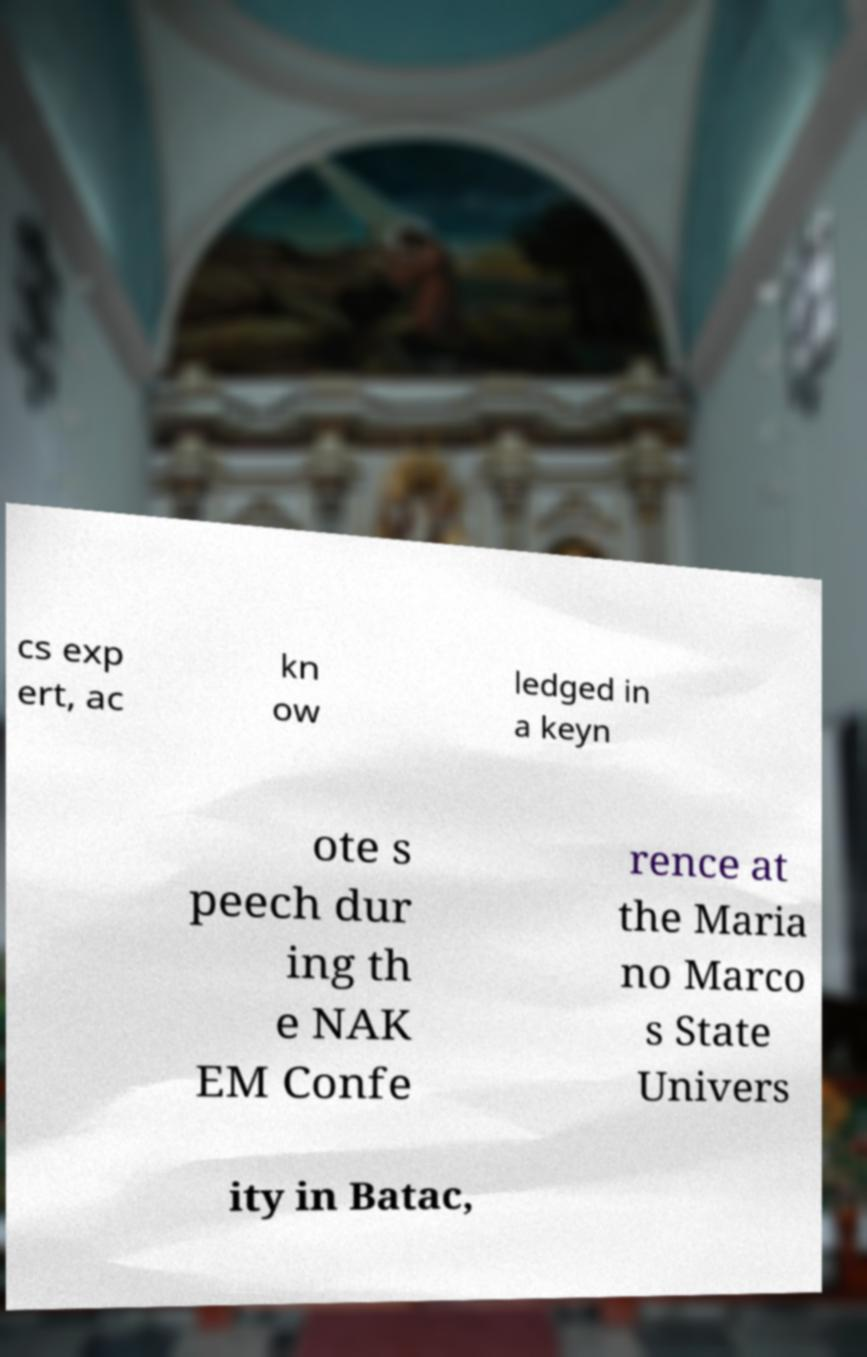What messages or text are displayed in this image? I need them in a readable, typed format. cs exp ert, ac kn ow ledged in a keyn ote s peech dur ing th e NAK EM Confe rence at the Maria no Marco s State Univers ity in Batac, 